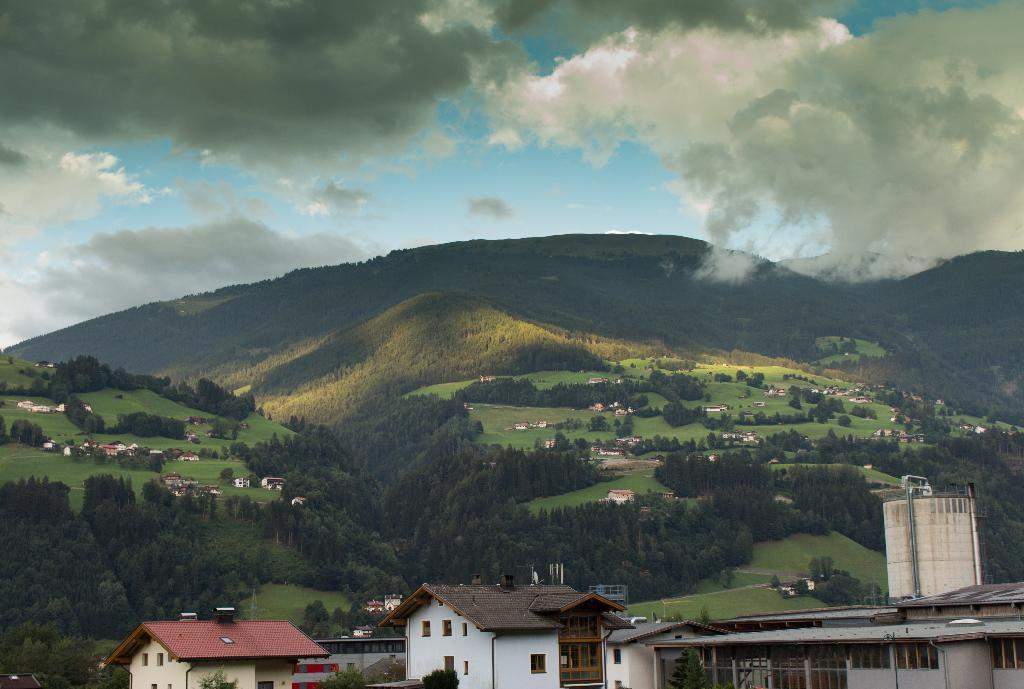What type of vegetation can be seen in the image? There are trees and grass in the image. What type of structures are visible in the image? There are houses in the image. What geographical features can be seen in the image? There are hills in the image. What is visible in the sky in the image? The sky is visible in the image, and clouds are present. What is the name of the person telling a joke in the image? There is no person telling a joke in the image; it only features trees, grass, houses, hills, sky, and clouds. 